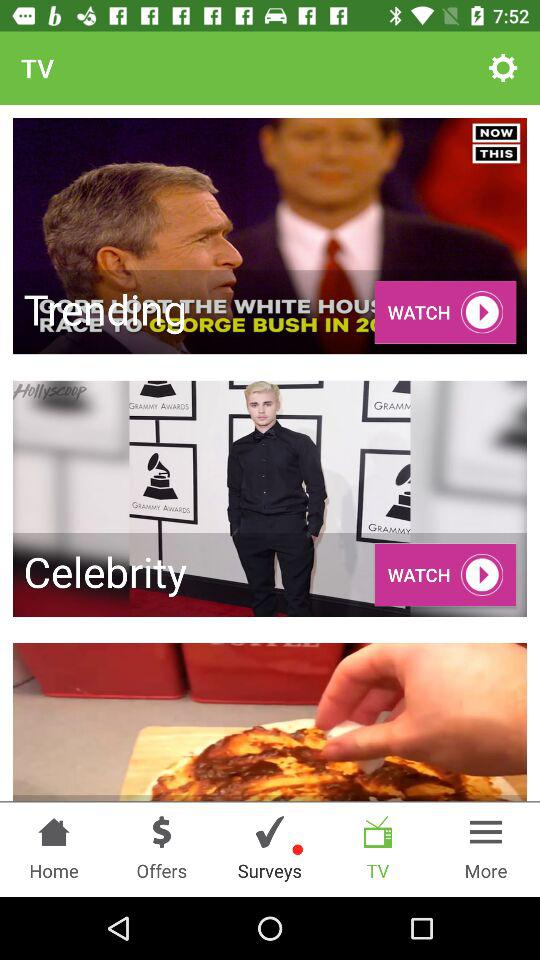Which tab is selected? The selected tab is "TV". 